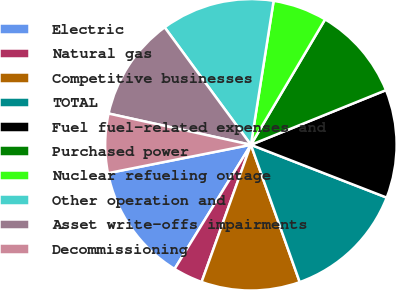Convert chart to OTSL. <chart><loc_0><loc_0><loc_500><loc_500><pie_chart><fcel>Electric<fcel>Natural gas<fcel>Competitive businesses<fcel>TOTAL<fcel>Fuel fuel-related expenses and<fcel>Purchased power<fcel>Nuclear refueling outage<fcel>Other operation and<fcel>Asset write-offs impairments<fcel>Decommissioning<nl><fcel>13.11%<fcel>3.28%<fcel>10.93%<fcel>13.66%<fcel>12.02%<fcel>10.38%<fcel>6.01%<fcel>12.57%<fcel>11.48%<fcel>6.56%<nl></chart> 